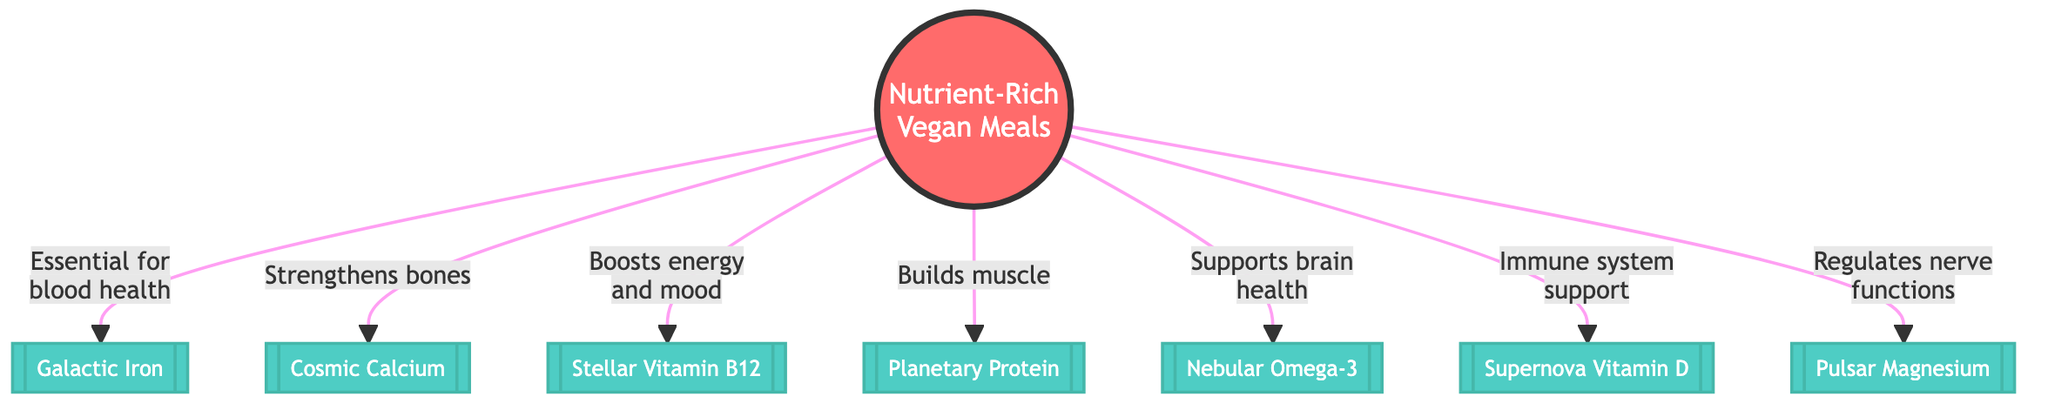What is the central theme of the diagram? The diagram centers around "Nutrient-Rich Vegan Meals," which is indicated by the node labeled as such at the center. This node serves as the starting point for connections to various nutrients.
Answer: Nutrient-Rich Vegan Meals How many nutrients are connected to the central node? Counting the connections from the central node, there are seven nutrients linked to "Nutrient-Rich Vegan Meals," each representing a specific nutrient and its benefits.
Answer: 7 Which nutrient is associated with immune system support? The connection labeled "Immune system support" leads to "Supernova Vitamin D," indicating that this nutrient is linked to supporting the immune system.
Answer: Supernova Vitamin D What benefit is associated with "Nebular Omega-3"? The label on the connection from "Nebular Omega-3" states that it "Supports brain health," identifying its specific benefit within the diagram.
Answer: Supports brain health Which nutrient helps in building muscle? The phrase "Builds muscle" is directly linked to the "Planetary Protein" node, showing that this nutrient is specifically identified as helping with muscle building.
Answer: Planetary Protein What relationship exists between "Galactic Iron" and blood health? The label connected to "Galactic Iron" specifies that it is "Essential for blood health," indicating a direct beneficial relationship between this nutrient and blood health.
Answer: Essential for blood health Which nutrient is linked with regulating nerve functions? The diagram illustrates that "Pulsar Magnesium" is tied to the benefit of "Regulates nerve functions," showing the connection of this nutrient to that specific physiological role.
Answer: Pulsar Magnesium What is the associated benefit of "Stellar Vitamin B12"? The relationship indicated in the connection suggests that "Stellar Vitamin B12" is associated with boosting "energy and mood," highlighting its beneficial impact.
Answer: Boosts energy and mood 